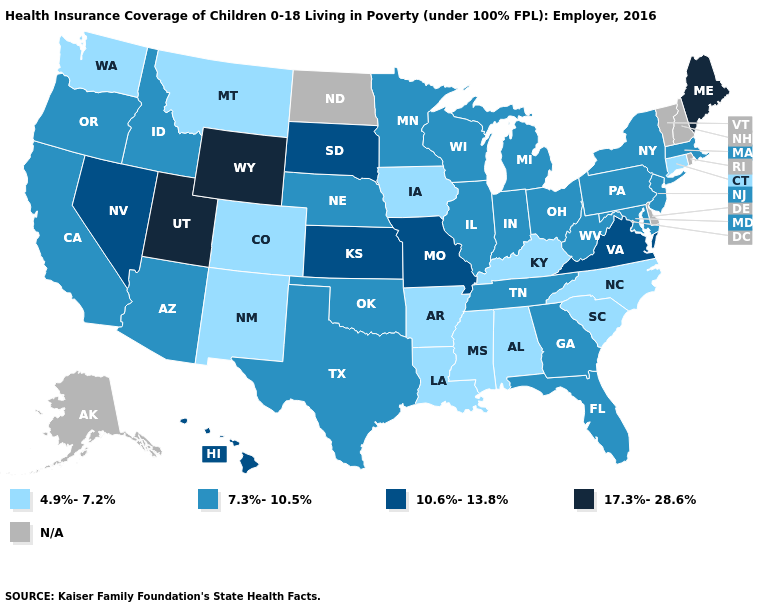What is the value of Minnesota?
Write a very short answer. 7.3%-10.5%. What is the value of North Dakota?
Concise answer only. N/A. Name the states that have a value in the range N/A?
Concise answer only. Alaska, Delaware, New Hampshire, North Dakota, Rhode Island, Vermont. What is the value of Nebraska?
Answer briefly. 7.3%-10.5%. Name the states that have a value in the range 7.3%-10.5%?
Give a very brief answer. Arizona, California, Florida, Georgia, Idaho, Illinois, Indiana, Maryland, Massachusetts, Michigan, Minnesota, Nebraska, New Jersey, New York, Ohio, Oklahoma, Oregon, Pennsylvania, Tennessee, Texas, West Virginia, Wisconsin. What is the lowest value in the USA?
Short answer required. 4.9%-7.2%. What is the highest value in states that border North Carolina?
Keep it brief. 10.6%-13.8%. Name the states that have a value in the range N/A?
Short answer required. Alaska, Delaware, New Hampshire, North Dakota, Rhode Island, Vermont. Which states hav the highest value in the South?
Be succinct. Virginia. Name the states that have a value in the range 4.9%-7.2%?
Write a very short answer. Alabama, Arkansas, Colorado, Connecticut, Iowa, Kentucky, Louisiana, Mississippi, Montana, New Mexico, North Carolina, South Carolina, Washington. How many symbols are there in the legend?
Quick response, please. 5. Does the first symbol in the legend represent the smallest category?
Keep it brief. Yes. Which states have the lowest value in the South?
Answer briefly. Alabama, Arkansas, Kentucky, Louisiana, Mississippi, North Carolina, South Carolina. 